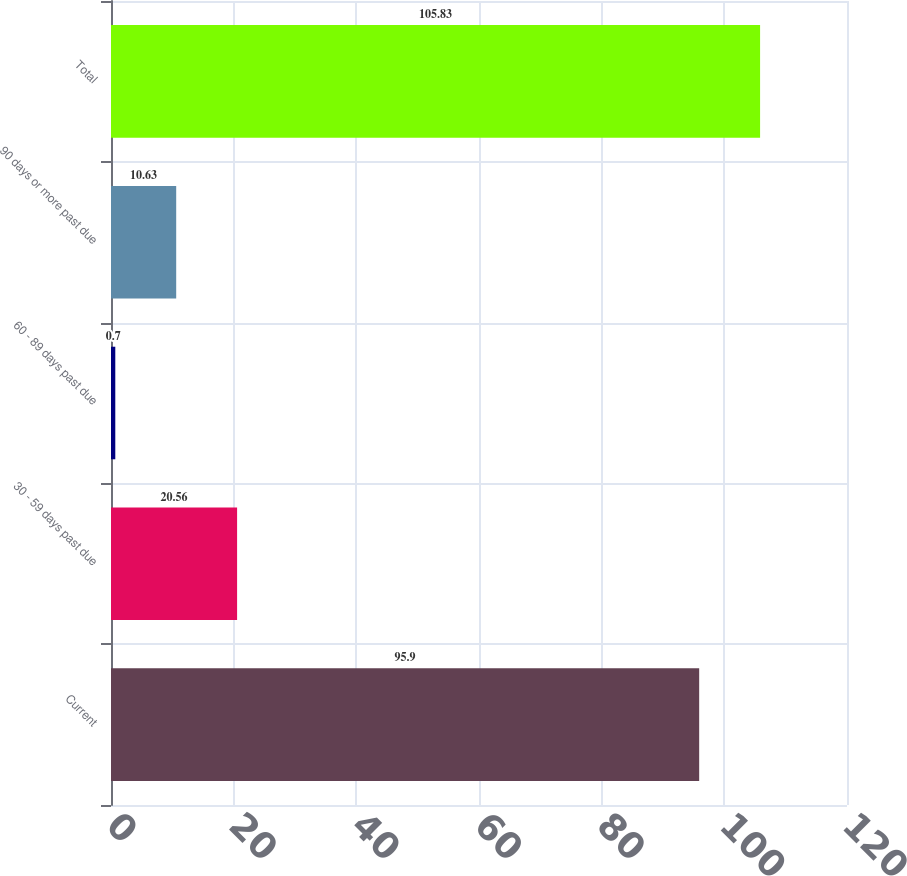Convert chart to OTSL. <chart><loc_0><loc_0><loc_500><loc_500><bar_chart><fcel>Current<fcel>30 - 59 days past due<fcel>60 - 89 days past due<fcel>90 days or more past due<fcel>Total<nl><fcel>95.9<fcel>20.56<fcel>0.7<fcel>10.63<fcel>105.83<nl></chart> 